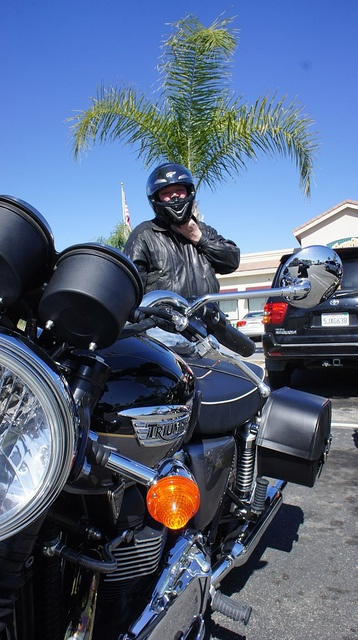Describe the objects in this image and their specific colors. I can see motorcycle in blue, black, gray, navy, and darkgray tones, people in blue, black, gray, navy, and darkgray tones, car in blue, black, gray, and lightgray tones, and car in blue, white, black, darkgray, and gray tones in this image. 